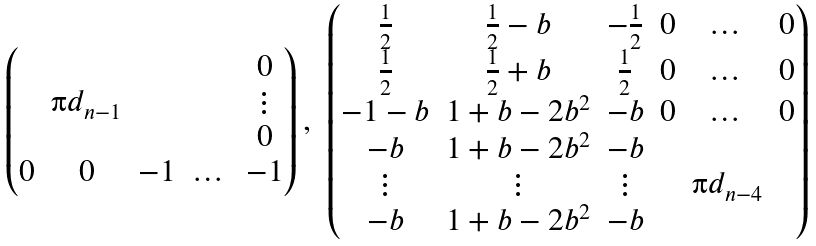Convert formula to latex. <formula><loc_0><loc_0><loc_500><loc_500>\begin{array} { c c } \begin{pmatrix} & & & & 0 \\ & \i d _ { n - 1 } & & & \vdots \\ & & & & 0 \\ 0 & 0 & - 1 & \dots & - 1 \end{pmatrix} , & \begin{pmatrix} \frac { 1 } { 2 } & \frac { 1 } { 2 } - b & - \frac { 1 } { 2 } & 0 & \dots & 0 \\ \frac { 1 } { 2 } & \frac { 1 } { 2 } + b & \frac { 1 } { 2 } & 0 & \dots & 0 \\ - 1 - b & 1 + b - 2 b ^ { 2 } & - b & 0 & \dots & 0 \\ - b & 1 + b - 2 b ^ { 2 } & - b & & & \\ \vdots & \vdots & \vdots & & \i d _ { n - 4 } & \\ - b & 1 + b - 2 b ^ { 2 } & - b & & & \end{pmatrix} \end{array}</formula> 